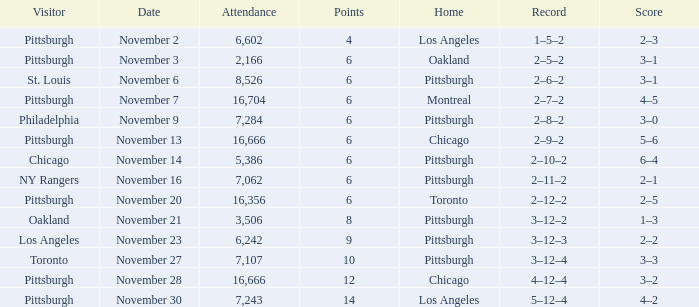What is the sum of the points of the game with philadelphia as the visitor and an attendance greater than 7,284? None. 